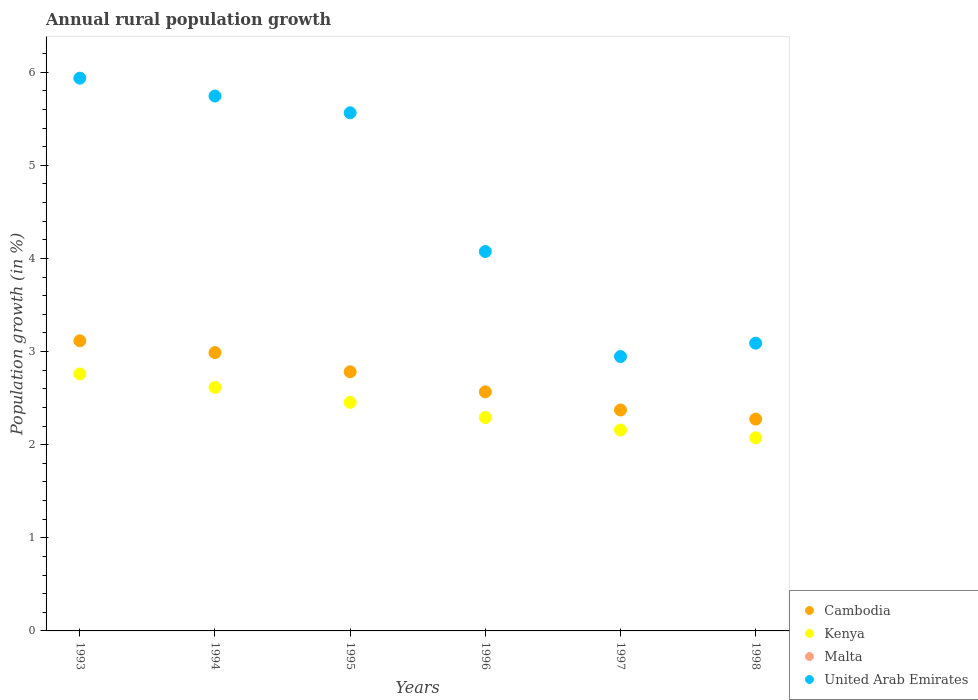Is the number of dotlines equal to the number of legend labels?
Provide a succinct answer. No. What is the percentage of rural population growth in United Arab Emirates in 1996?
Give a very brief answer. 4.07. Across all years, what is the maximum percentage of rural population growth in Cambodia?
Make the answer very short. 3.12. Across all years, what is the minimum percentage of rural population growth in United Arab Emirates?
Your answer should be very brief. 2.95. In which year was the percentage of rural population growth in Kenya maximum?
Your answer should be very brief. 1993. What is the difference between the percentage of rural population growth in Cambodia in 1994 and that in 1996?
Make the answer very short. 0.42. What is the difference between the percentage of rural population growth in Cambodia in 1994 and the percentage of rural population growth in Malta in 1997?
Your response must be concise. 2.99. What is the average percentage of rural population growth in Cambodia per year?
Your response must be concise. 2.68. In the year 1995, what is the difference between the percentage of rural population growth in Kenya and percentage of rural population growth in Cambodia?
Offer a very short reply. -0.33. What is the ratio of the percentage of rural population growth in United Arab Emirates in 1996 to that in 1997?
Provide a short and direct response. 1.38. What is the difference between the highest and the second highest percentage of rural population growth in Cambodia?
Provide a short and direct response. 0.13. What is the difference between the highest and the lowest percentage of rural population growth in United Arab Emirates?
Your answer should be compact. 2.99. How many years are there in the graph?
Give a very brief answer. 6. Are the values on the major ticks of Y-axis written in scientific E-notation?
Provide a short and direct response. No. Does the graph contain any zero values?
Provide a short and direct response. Yes. Does the graph contain grids?
Your response must be concise. No. Where does the legend appear in the graph?
Offer a terse response. Bottom right. What is the title of the graph?
Your response must be concise. Annual rural population growth. Does "Liberia" appear as one of the legend labels in the graph?
Provide a succinct answer. No. What is the label or title of the Y-axis?
Offer a very short reply. Population growth (in %). What is the Population growth (in %) in Cambodia in 1993?
Ensure brevity in your answer.  3.12. What is the Population growth (in %) in Kenya in 1993?
Provide a short and direct response. 2.76. What is the Population growth (in %) of Malta in 1993?
Provide a succinct answer. 0. What is the Population growth (in %) of United Arab Emirates in 1993?
Your answer should be compact. 5.94. What is the Population growth (in %) of Cambodia in 1994?
Give a very brief answer. 2.99. What is the Population growth (in %) in Kenya in 1994?
Keep it short and to the point. 2.61. What is the Population growth (in %) of United Arab Emirates in 1994?
Your answer should be very brief. 5.74. What is the Population growth (in %) in Cambodia in 1995?
Offer a very short reply. 2.78. What is the Population growth (in %) in Kenya in 1995?
Your response must be concise. 2.45. What is the Population growth (in %) in Malta in 1995?
Your response must be concise. 0. What is the Population growth (in %) in United Arab Emirates in 1995?
Provide a succinct answer. 5.56. What is the Population growth (in %) of Cambodia in 1996?
Your answer should be very brief. 2.57. What is the Population growth (in %) in Kenya in 1996?
Your answer should be very brief. 2.29. What is the Population growth (in %) in United Arab Emirates in 1996?
Offer a very short reply. 4.07. What is the Population growth (in %) in Cambodia in 1997?
Give a very brief answer. 2.37. What is the Population growth (in %) in Kenya in 1997?
Your response must be concise. 2.16. What is the Population growth (in %) of Malta in 1997?
Your answer should be compact. 0. What is the Population growth (in %) in United Arab Emirates in 1997?
Make the answer very short. 2.95. What is the Population growth (in %) of Cambodia in 1998?
Your answer should be very brief. 2.27. What is the Population growth (in %) of Kenya in 1998?
Provide a short and direct response. 2.07. What is the Population growth (in %) of United Arab Emirates in 1998?
Offer a terse response. 3.09. Across all years, what is the maximum Population growth (in %) of Cambodia?
Your response must be concise. 3.12. Across all years, what is the maximum Population growth (in %) of Kenya?
Your answer should be compact. 2.76. Across all years, what is the maximum Population growth (in %) of United Arab Emirates?
Give a very brief answer. 5.94. Across all years, what is the minimum Population growth (in %) of Cambodia?
Give a very brief answer. 2.27. Across all years, what is the minimum Population growth (in %) in Kenya?
Provide a succinct answer. 2.07. Across all years, what is the minimum Population growth (in %) of United Arab Emirates?
Your response must be concise. 2.95. What is the total Population growth (in %) in Cambodia in the graph?
Give a very brief answer. 16.1. What is the total Population growth (in %) in Kenya in the graph?
Your answer should be very brief. 14.35. What is the total Population growth (in %) in United Arab Emirates in the graph?
Your response must be concise. 27.35. What is the difference between the Population growth (in %) in Cambodia in 1993 and that in 1994?
Your answer should be compact. 0.13. What is the difference between the Population growth (in %) of Kenya in 1993 and that in 1994?
Your answer should be very brief. 0.14. What is the difference between the Population growth (in %) in United Arab Emirates in 1993 and that in 1994?
Ensure brevity in your answer.  0.19. What is the difference between the Population growth (in %) of Cambodia in 1993 and that in 1995?
Make the answer very short. 0.33. What is the difference between the Population growth (in %) of Kenya in 1993 and that in 1995?
Your answer should be very brief. 0.3. What is the difference between the Population growth (in %) of United Arab Emirates in 1993 and that in 1995?
Offer a very short reply. 0.37. What is the difference between the Population growth (in %) in Cambodia in 1993 and that in 1996?
Provide a succinct answer. 0.55. What is the difference between the Population growth (in %) in Kenya in 1993 and that in 1996?
Your answer should be very brief. 0.47. What is the difference between the Population growth (in %) in United Arab Emirates in 1993 and that in 1996?
Ensure brevity in your answer.  1.86. What is the difference between the Population growth (in %) of Cambodia in 1993 and that in 1997?
Ensure brevity in your answer.  0.74. What is the difference between the Population growth (in %) of Kenya in 1993 and that in 1997?
Your response must be concise. 0.6. What is the difference between the Population growth (in %) of United Arab Emirates in 1993 and that in 1997?
Make the answer very short. 2.99. What is the difference between the Population growth (in %) of Cambodia in 1993 and that in 1998?
Offer a very short reply. 0.84. What is the difference between the Population growth (in %) of Kenya in 1993 and that in 1998?
Give a very brief answer. 0.69. What is the difference between the Population growth (in %) of United Arab Emirates in 1993 and that in 1998?
Make the answer very short. 2.85. What is the difference between the Population growth (in %) of Cambodia in 1994 and that in 1995?
Give a very brief answer. 0.21. What is the difference between the Population growth (in %) in Kenya in 1994 and that in 1995?
Your response must be concise. 0.16. What is the difference between the Population growth (in %) in United Arab Emirates in 1994 and that in 1995?
Your answer should be very brief. 0.18. What is the difference between the Population growth (in %) of Cambodia in 1994 and that in 1996?
Your response must be concise. 0.42. What is the difference between the Population growth (in %) of Kenya in 1994 and that in 1996?
Provide a short and direct response. 0.32. What is the difference between the Population growth (in %) in United Arab Emirates in 1994 and that in 1996?
Provide a short and direct response. 1.67. What is the difference between the Population growth (in %) in Cambodia in 1994 and that in 1997?
Give a very brief answer. 0.62. What is the difference between the Population growth (in %) in Kenya in 1994 and that in 1997?
Offer a terse response. 0.46. What is the difference between the Population growth (in %) of United Arab Emirates in 1994 and that in 1997?
Offer a very short reply. 2.8. What is the difference between the Population growth (in %) in Cambodia in 1994 and that in 1998?
Your answer should be very brief. 0.71. What is the difference between the Population growth (in %) in Kenya in 1994 and that in 1998?
Offer a terse response. 0.54. What is the difference between the Population growth (in %) in United Arab Emirates in 1994 and that in 1998?
Offer a very short reply. 2.65. What is the difference between the Population growth (in %) in Cambodia in 1995 and that in 1996?
Provide a short and direct response. 0.22. What is the difference between the Population growth (in %) in Kenya in 1995 and that in 1996?
Ensure brevity in your answer.  0.16. What is the difference between the Population growth (in %) in United Arab Emirates in 1995 and that in 1996?
Your answer should be compact. 1.49. What is the difference between the Population growth (in %) of Cambodia in 1995 and that in 1997?
Offer a very short reply. 0.41. What is the difference between the Population growth (in %) of Kenya in 1995 and that in 1997?
Ensure brevity in your answer.  0.3. What is the difference between the Population growth (in %) of United Arab Emirates in 1995 and that in 1997?
Ensure brevity in your answer.  2.62. What is the difference between the Population growth (in %) in Cambodia in 1995 and that in 1998?
Offer a terse response. 0.51. What is the difference between the Population growth (in %) in Kenya in 1995 and that in 1998?
Give a very brief answer. 0.38. What is the difference between the Population growth (in %) of United Arab Emirates in 1995 and that in 1998?
Provide a short and direct response. 2.47. What is the difference between the Population growth (in %) of Cambodia in 1996 and that in 1997?
Your answer should be very brief. 0.19. What is the difference between the Population growth (in %) in Kenya in 1996 and that in 1997?
Give a very brief answer. 0.13. What is the difference between the Population growth (in %) of United Arab Emirates in 1996 and that in 1997?
Ensure brevity in your answer.  1.13. What is the difference between the Population growth (in %) in Cambodia in 1996 and that in 1998?
Keep it short and to the point. 0.29. What is the difference between the Population growth (in %) in Kenya in 1996 and that in 1998?
Make the answer very short. 0.22. What is the difference between the Population growth (in %) of United Arab Emirates in 1996 and that in 1998?
Provide a short and direct response. 0.98. What is the difference between the Population growth (in %) in Cambodia in 1997 and that in 1998?
Your answer should be very brief. 0.1. What is the difference between the Population growth (in %) of Kenya in 1997 and that in 1998?
Give a very brief answer. 0.08. What is the difference between the Population growth (in %) of United Arab Emirates in 1997 and that in 1998?
Provide a succinct answer. -0.14. What is the difference between the Population growth (in %) in Cambodia in 1993 and the Population growth (in %) in Kenya in 1994?
Your answer should be compact. 0.5. What is the difference between the Population growth (in %) in Cambodia in 1993 and the Population growth (in %) in United Arab Emirates in 1994?
Ensure brevity in your answer.  -2.63. What is the difference between the Population growth (in %) of Kenya in 1993 and the Population growth (in %) of United Arab Emirates in 1994?
Your answer should be compact. -2.98. What is the difference between the Population growth (in %) of Cambodia in 1993 and the Population growth (in %) of Kenya in 1995?
Keep it short and to the point. 0.66. What is the difference between the Population growth (in %) in Cambodia in 1993 and the Population growth (in %) in United Arab Emirates in 1995?
Offer a very short reply. -2.45. What is the difference between the Population growth (in %) of Kenya in 1993 and the Population growth (in %) of United Arab Emirates in 1995?
Provide a succinct answer. -2.8. What is the difference between the Population growth (in %) in Cambodia in 1993 and the Population growth (in %) in Kenya in 1996?
Provide a short and direct response. 0.82. What is the difference between the Population growth (in %) in Cambodia in 1993 and the Population growth (in %) in United Arab Emirates in 1996?
Your response must be concise. -0.96. What is the difference between the Population growth (in %) in Kenya in 1993 and the Population growth (in %) in United Arab Emirates in 1996?
Keep it short and to the point. -1.31. What is the difference between the Population growth (in %) of Cambodia in 1993 and the Population growth (in %) of Kenya in 1997?
Your answer should be very brief. 0.96. What is the difference between the Population growth (in %) in Cambodia in 1993 and the Population growth (in %) in United Arab Emirates in 1997?
Your answer should be compact. 0.17. What is the difference between the Population growth (in %) in Kenya in 1993 and the Population growth (in %) in United Arab Emirates in 1997?
Provide a succinct answer. -0.19. What is the difference between the Population growth (in %) in Cambodia in 1993 and the Population growth (in %) in Kenya in 1998?
Offer a terse response. 1.04. What is the difference between the Population growth (in %) of Cambodia in 1993 and the Population growth (in %) of United Arab Emirates in 1998?
Keep it short and to the point. 0.03. What is the difference between the Population growth (in %) of Kenya in 1993 and the Population growth (in %) of United Arab Emirates in 1998?
Your answer should be compact. -0.33. What is the difference between the Population growth (in %) of Cambodia in 1994 and the Population growth (in %) of Kenya in 1995?
Offer a very short reply. 0.53. What is the difference between the Population growth (in %) of Cambodia in 1994 and the Population growth (in %) of United Arab Emirates in 1995?
Provide a short and direct response. -2.58. What is the difference between the Population growth (in %) in Kenya in 1994 and the Population growth (in %) in United Arab Emirates in 1995?
Provide a short and direct response. -2.95. What is the difference between the Population growth (in %) in Cambodia in 1994 and the Population growth (in %) in Kenya in 1996?
Your answer should be compact. 0.7. What is the difference between the Population growth (in %) of Cambodia in 1994 and the Population growth (in %) of United Arab Emirates in 1996?
Offer a very short reply. -1.09. What is the difference between the Population growth (in %) in Kenya in 1994 and the Population growth (in %) in United Arab Emirates in 1996?
Your answer should be very brief. -1.46. What is the difference between the Population growth (in %) in Cambodia in 1994 and the Population growth (in %) in Kenya in 1997?
Your answer should be compact. 0.83. What is the difference between the Population growth (in %) of Cambodia in 1994 and the Population growth (in %) of United Arab Emirates in 1997?
Offer a very short reply. 0.04. What is the difference between the Population growth (in %) in Kenya in 1994 and the Population growth (in %) in United Arab Emirates in 1997?
Provide a short and direct response. -0.33. What is the difference between the Population growth (in %) in Cambodia in 1994 and the Population growth (in %) in Kenya in 1998?
Your answer should be very brief. 0.92. What is the difference between the Population growth (in %) in Cambodia in 1994 and the Population growth (in %) in United Arab Emirates in 1998?
Offer a terse response. -0.1. What is the difference between the Population growth (in %) in Kenya in 1994 and the Population growth (in %) in United Arab Emirates in 1998?
Your answer should be very brief. -0.48. What is the difference between the Population growth (in %) in Cambodia in 1995 and the Population growth (in %) in Kenya in 1996?
Make the answer very short. 0.49. What is the difference between the Population growth (in %) in Cambodia in 1995 and the Population growth (in %) in United Arab Emirates in 1996?
Your answer should be very brief. -1.29. What is the difference between the Population growth (in %) in Kenya in 1995 and the Population growth (in %) in United Arab Emirates in 1996?
Provide a short and direct response. -1.62. What is the difference between the Population growth (in %) of Cambodia in 1995 and the Population growth (in %) of Kenya in 1997?
Ensure brevity in your answer.  0.63. What is the difference between the Population growth (in %) in Cambodia in 1995 and the Population growth (in %) in United Arab Emirates in 1997?
Your response must be concise. -0.16. What is the difference between the Population growth (in %) of Kenya in 1995 and the Population growth (in %) of United Arab Emirates in 1997?
Give a very brief answer. -0.49. What is the difference between the Population growth (in %) in Cambodia in 1995 and the Population growth (in %) in Kenya in 1998?
Make the answer very short. 0.71. What is the difference between the Population growth (in %) of Cambodia in 1995 and the Population growth (in %) of United Arab Emirates in 1998?
Offer a terse response. -0.31. What is the difference between the Population growth (in %) in Kenya in 1995 and the Population growth (in %) in United Arab Emirates in 1998?
Your answer should be compact. -0.64. What is the difference between the Population growth (in %) of Cambodia in 1996 and the Population growth (in %) of Kenya in 1997?
Provide a short and direct response. 0.41. What is the difference between the Population growth (in %) of Cambodia in 1996 and the Population growth (in %) of United Arab Emirates in 1997?
Your answer should be compact. -0.38. What is the difference between the Population growth (in %) in Kenya in 1996 and the Population growth (in %) in United Arab Emirates in 1997?
Provide a short and direct response. -0.66. What is the difference between the Population growth (in %) of Cambodia in 1996 and the Population growth (in %) of Kenya in 1998?
Offer a very short reply. 0.49. What is the difference between the Population growth (in %) in Cambodia in 1996 and the Population growth (in %) in United Arab Emirates in 1998?
Keep it short and to the point. -0.52. What is the difference between the Population growth (in %) of Kenya in 1996 and the Population growth (in %) of United Arab Emirates in 1998?
Make the answer very short. -0.8. What is the difference between the Population growth (in %) in Cambodia in 1997 and the Population growth (in %) in Kenya in 1998?
Keep it short and to the point. 0.3. What is the difference between the Population growth (in %) in Cambodia in 1997 and the Population growth (in %) in United Arab Emirates in 1998?
Your answer should be very brief. -0.72. What is the difference between the Population growth (in %) of Kenya in 1997 and the Population growth (in %) of United Arab Emirates in 1998?
Give a very brief answer. -0.93. What is the average Population growth (in %) of Cambodia per year?
Keep it short and to the point. 2.68. What is the average Population growth (in %) in Kenya per year?
Keep it short and to the point. 2.39. What is the average Population growth (in %) of Malta per year?
Provide a succinct answer. 0. What is the average Population growth (in %) in United Arab Emirates per year?
Your response must be concise. 4.56. In the year 1993, what is the difference between the Population growth (in %) in Cambodia and Population growth (in %) in Kenya?
Offer a terse response. 0.36. In the year 1993, what is the difference between the Population growth (in %) of Cambodia and Population growth (in %) of United Arab Emirates?
Your answer should be very brief. -2.82. In the year 1993, what is the difference between the Population growth (in %) of Kenya and Population growth (in %) of United Arab Emirates?
Offer a very short reply. -3.18. In the year 1994, what is the difference between the Population growth (in %) of Cambodia and Population growth (in %) of Kenya?
Your answer should be very brief. 0.37. In the year 1994, what is the difference between the Population growth (in %) in Cambodia and Population growth (in %) in United Arab Emirates?
Ensure brevity in your answer.  -2.76. In the year 1994, what is the difference between the Population growth (in %) in Kenya and Population growth (in %) in United Arab Emirates?
Give a very brief answer. -3.13. In the year 1995, what is the difference between the Population growth (in %) in Cambodia and Population growth (in %) in Kenya?
Your response must be concise. 0.33. In the year 1995, what is the difference between the Population growth (in %) in Cambodia and Population growth (in %) in United Arab Emirates?
Provide a short and direct response. -2.78. In the year 1995, what is the difference between the Population growth (in %) in Kenya and Population growth (in %) in United Arab Emirates?
Offer a terse response. -3.11. In the year 1996, what is the difference between the Population growth (in %) of Cambodia and Population growth (in %) of Kenya?
Your response must be concise. 0.28. In the year 1996, what is the difference between the Population growth (in %) of Cambodia and Population growth (in %) of United Arab Emirates?
Give a very brief answer. -1.51. In the year 1996, what is the difference between the Population growth (in %) of Kenya and Population growth (in %) of United Arab Emirates?
Your response must be concise. -1.78. In the year 1997, what is the difference between the Population growth (in %) in Cambodia and Population growth (in %) in Kenya?
Your answer should be very brief. 0.21. In the year 1997, what is the difference between the Population growth (in %) of Cambodia and Population growth (in %) of United Arab Emirates?
Keep it short and to the point. -0.57. In the year 1997, what is the difference between the Population growth (in %) of Kenya and Population growth (in %) of United Arab Emirates?
Provide a short and direct response. -0.79. In the year 1998, what is the difference between the Population growth (in %) in Cambodia and Population growth (in %) in Kenya?
Your answer should be compact. 0.2. In the year 1998, what is the difference between the Population growth (in %) in Cambodia and Population growth (in %) in United Arab Emirates?
Offer a terse response. -0.82. In the year 1998, what is the difference between the Population growth (in %) in Kenya and Population growth (in %) in United Arab Emirates?
Ensure brevity in your answer.  -1.02. What is the ratio of the Population growth (in %) in Cambodia in 1993 to that in 1994?
Your answer should be very brief. 1.04. What is the ratio of the Population growth (in %) of Kenya in 1993 to that in 1994?
Your response must be concise. 1.06. What is the ratio of the Population growth (in %) in United Arab Emirates in 1993 to that in 1994?
Your answer should be very brief. 1.03. What is the ratio of the Population growth (in %) in Cambodia in 1993 to that in 1995?
Keep it short and to the point. 1.12. What is the ratio of the Population growth (in %) of Kenya in 1993 to that in 1995?
Provide a short and direct response. 1.12. What is the ratio of the Population growth (in %) in United Arab Emirates in 1993 to that in 1995?
Offer a terse response. 1.07. What is the ratio of the Population growth (in %) in Cambodia in 1993 to that in 1996?
Your answer should be very brief. 1.21. What is the ratio of the Population growth (in %) in Kenya in 1993 to that in 1996?
Provide a short and direct response. 1.2. What is the ratio of the Population growth (in %) of United Arab Emirates in 1993 to that in 1996?
Your response must be concise. 1.46. What is the ratio of the Population growth (in %) of Cambodia in 1993 to that in 1997?
Make the answer very short. 1.31. What is the ratio of the Population growth (in %) in Kenya in 1993 to that in 1997?
Provide a short and direct response. 1.28. What is the ratio of the Population growth (in %) in United Arab Emirates in 1993 to that in 1997?
Keep it short and to the point. 2.01. What is the ratio of the Population growth (in %) in Cambodia in 1993 to that in 1998?
Make the answer very short. 1.37. What is the ratio of the Population growth (in %) in Kenya in 1993 to that in 1998?
Your answer should be very brief. 1.33. What is the ratio of the Population growth (in %) of United Arab Emirates in 1993 to that in 1998?
Keep it short and to the point. 1.92. What is the ratio of the Population growth (in %) of Cambodia in 1994 to that in 1995?
Your response must be concise. 1.07. What is the ratio of the Population growth (in %) of Kenya in 1994 to that in 1995?
Ensure brevity in your answer.  1.07. What is the ratio of the Population growth (in %) of United Arab Emirates in 1994 to that in 1995?
Ensure brevity in your answer.  1.03. What is the ratio of the Population growth (in %) in Cambodia in 1994 to that in 1996?
Provide a short and direct response. 1.16. What is the ratio of the Population growth (in %) of Kenya in 1994 to that in 1996?
Your answer should be very brief. 1.14. What is the ratio of the Population growth (in %) in United Arab Emirates in 1994 to that in 1996?
Make the answer very short. 1.41. What is the ratio of the Population growth (in %) in Cambodia in 1994 to that in 1997?
Your answer should be compact. 1.26. What is the ratio of the Population growth (in %) of Kenya in 1994 to that in 1997?
Keep it short and to the point. 1.21. What is the ratio of the Population growth (in %) of United Arab Emirates in 1994 to that in 1997?
Offer a very short reply. 1.95. What is the ratio of the Population growth (in %) of Cambodia in 1994 to that in 1998?
Your answer should be compact. 1.31. What is the ratio of the Population growth (in %) of Kenya in 1994 to that in 1998?
Offer a terse response. 1.26. What is the ratio of the Population growth (in %) in United Arab Emirates in 1994 to that in 1998?
Your answer should be very brief. 1.86. What is the ratio of the Population growth (in %) of Cambodia in 1995 to that in 1996?
Your response must be concise. 1.08. What is the ratio of the Population growth (in %) in Kenya in 1995 to that in 1996?
Make the answer very short. 1.07. What is the ratio of the Population growth (in %) of United Arab Emirates in 1995 to that in 1996?
Provide a succinct answer. 1.37. What is the ratio of the Population growth (in %) in Cambodia in 1995 to that in 1997?
Keep it short and to the point. 1.17. What is the ratio of the Population growth (in %) in Kenya in 1995 to that in 1997?
Provide a short and direct response. 1.14. What is the ratio of the Population growth (in %) in United Arab Emirates in 1995 to that in 1997?
Your answer should be compact. 1.89. What is the ratio of the Population growth (in %) of Cambodia in 1995 to that in 1998?
Your answer should be compact. 1.22. What is the ratio of the Population growth (in %) in Kenya in 1995 to that in 1998?
Offer a terse response. 1.18. What is the ratio of the Population growth (in %) of United Arab Emirates in 1995 to that in 1998?
Provide a short and direct response. 1.8. What is the ratio of the Population growth (in %) of Cambodia in 1996 to that in 1997?
Ensure brevity in your answer.  1.08. What is the ratio of the Population growth (in %) of Kenya in 1996 to that in 1997?
Offer a very short reply. 1.06. What is the ratio of the Population growth (in %) of United Arab Emirates in 1996 to that in 1997?
Offer a terse response. 1.38. What is the ratio of the Population growth (in %) of Cambodia in 1996 to that in 1998?
Your answer should be very brief. 1.13. What is the ratio of the Population growth (in %) in Kenya in 1996 to that in 1998?
Make the answer very short. 1.1. What is the ratio of the Population growth (in %) of United Arab Emirates in 1996 to that in 1998?
Your answer should be very brief. 1.32. What is the ratio of the Population growth (in %) in Cambodia in 1997 to that in 1998?
Provide a succinct answer. 1.04. What is the ratio of the Population growth (in %) of Kenya in 1997 to that in 1998?
Keep it short and to the point. 1.04. What is the ratio of the Population growth (in %) in United Arab Emirates in 1997 to that in 1998?
Keep it short and to the point. 0.95. What is the difference between the highest and the second highest Population growth (in %) of Cambodia?
Your answer should be compact. 0.13. What is the difference between the highest and the second highest Population growth (in %) of Kenya?
Your response must be concise. 0.14. What is the difference between the highest and the second highest Population growth (in %) of United Arab Emirates?
Offer a terse response. 0.19. What is the difference between the highest and the lowest Population growth (in %) in Cambodia?
Provide a short and direct response. 0.84. What is the difference between the highest and the lowest Population growth (in %) of Kenya?
Offer a terse response. 0.69. What is the difference between the highest and the lowest Population growth (in %) of United Arab Emirates?
Give a very brief answer. 2.99. 